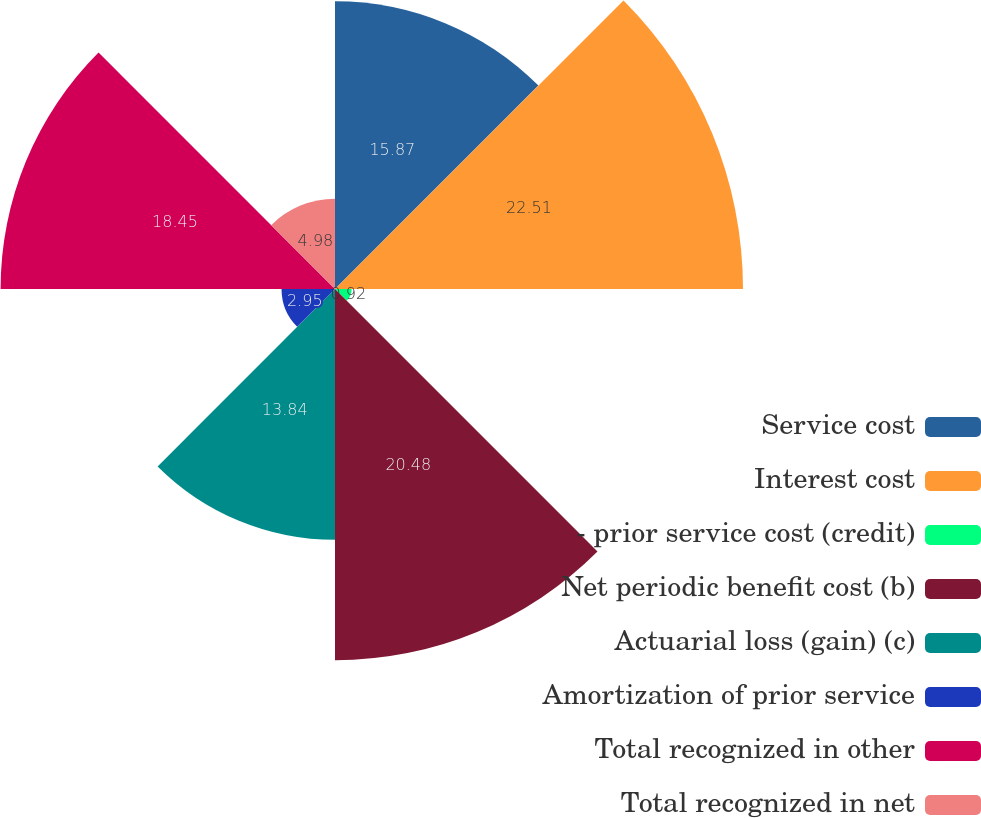Convert chart to OTSL. <chart><loc_0><loc_0><loc_500><loc_500><pie_chart><fcel>Service cost<fcel>Interest cost<fcel>- prior service cost (credit)<fcel>Net periodic benefit cost (b)<fcel>Actuarial loss (gain) (c)<fcel>Amortization of prior service<fcel>Total recognized in other<fcel>Total recognized in net<nl><fcel>15.87%<fcel>22.51%<fcel>0.92%<fcel>20.48%<fcel>13.84%<fcel>2.95%<fcel>18.45%<fcel>4.98%<nl></chart> 